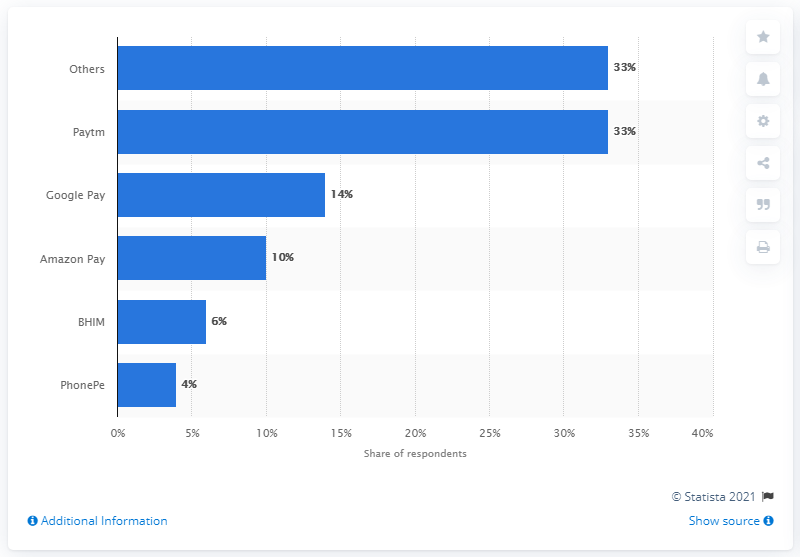Give some essential details in this illustration. In the survey, the majority of respondents reported using Paytm to make digital payments. 